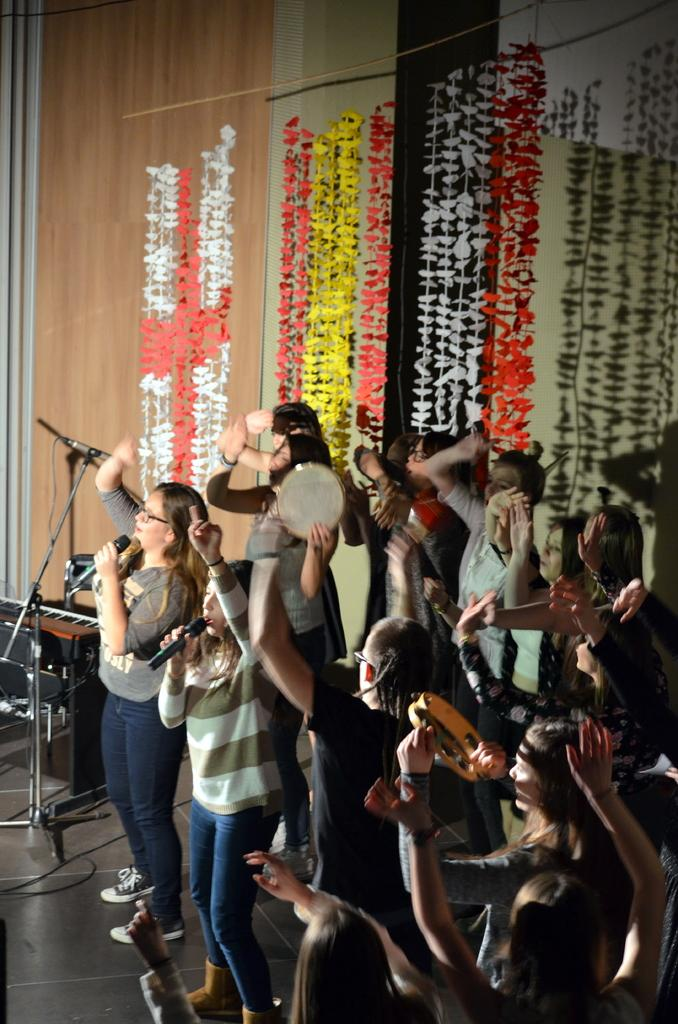What are the people in the image doing? Some of the people are playing musical instruments, and some are holding microphones. What can be seen in the background of the image? There are decorations, a piano, and a stand in the background of the image. What type of vegetable is being used as a crayon by the people in the image? There is no vegetable or crayon present in the image; the people are holding musical instruments and microphones. 